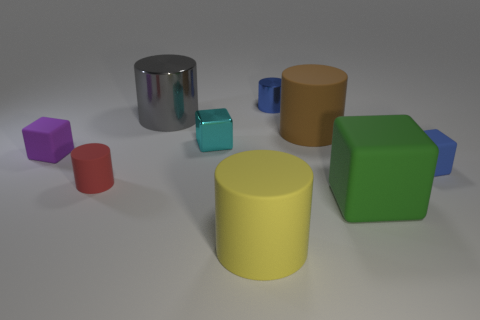There is a large cylinder that is to the left of the large yellow object; what number of rubber cubes are left of it?
Ensure brevity in your answer.  1. What material is the small cylinder that is right of the tiny cylinder that is in front of the small cylinder behind the cyan block made of?
Offer a very short reply. Metal. What is the cylinder that is on the left side of the cyan metal block and behind the large brown cylinder made of?
Your answer should be very brief. Metal. How many big gray things are the same shape as the green thing?
Give a very brief answer. 0. There is a rubber block left of the large cylinder in front of the big brown cylinder; what size is it?
Offer a terse response. Small. Does the block in front of the small matte cylinder have the same color as the thing in front of the green object?
Ensure brevity in your answer.  No. What number of red rubber objects are right of the block that is to the right of the cube in front of the blue matte block?
Provide a succinct answer. 0. What number of objects are to the left of the yellow matte cylinder and in front of the brown thing?
Make the answer very short. 3. Are there more large rubber objects to the left of the brown rubber thing than blue metal balls?
Your answer should be compact. Yes. How many cyan cubes have the same size as the brown object?
Offer a terse response. 0. 